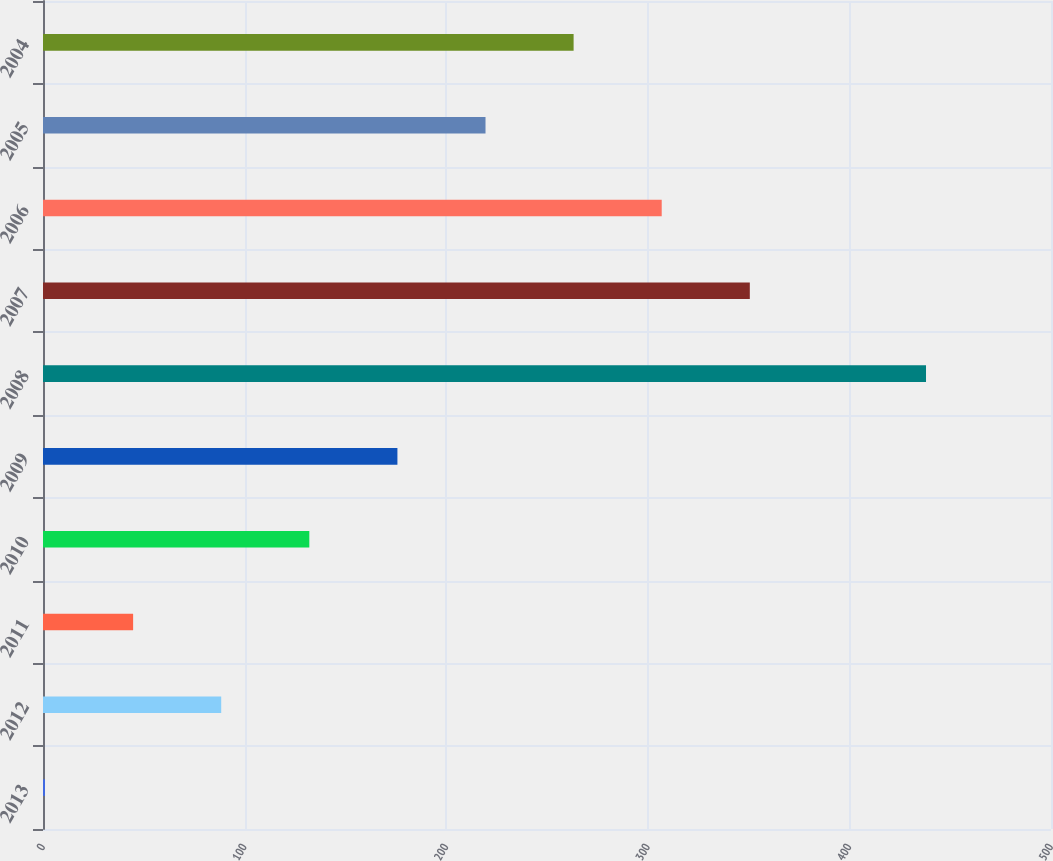<chart> <loc_0><loc_0><loc_500><loc_500><bar_chart><fcel>2013<fcel>2012<fcel>2011<fcel>2010<fcel>2009<fcel>2008<fcel>2007<fcel>2006<fcel>2005<fcel>2004<nl><fcel>1<fcel>88.4<fcel>44.7<fcel>132.1<fcel>175.8<fcel>438<fcel>350.6<fcel>306.9<fcel>219.5<fcel>263.2<nl></chart> 